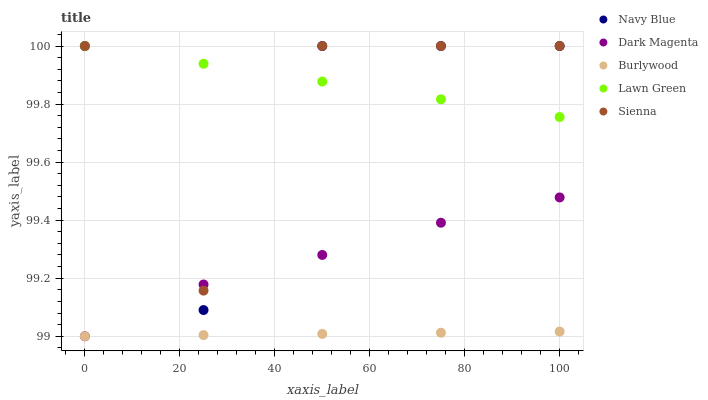Does Burlywood have the minimum area under the curve?
Answer yes or no. Yes. Does Lawn Green have the maximum area under the curve?
Answer yes or no. Yes. Does Navy Blue have the minimum area under the curve?
Answer yes or no. No. Does Navy Blue have the maximum area under the curve?
Answer yes or no. No. Is Lawn Green the smoothest?
Answer yes or no. Yes. Is Navy Blue the roughest?
Answer yes or no. Yes. Is Sienna the smoothest?
Answer yes or no. No. Is Sienna the roughest?
Answer yes or no. No. Does Burlywood have the lowest value?
Answer yes or no. Yes. Does Navy Blue have the lowest value?
Answer yes or no. No. Does Lawn Green have the highest value?
Answer yes or no. Yes. Does Dark Magenta have the highest value?
Answer yes or no. No. Is Dark Magenta less than Lawn Green?
Answer yes or no. Yes. Is Navy Blue greater than Burlywood?
Answer yes or no. Yes. Does Sienna intersect Navy Blue?
Answer yes or no. Yes. Is Sienna less than Navy Blue?
Answer yes or no. No. Is Sienna greater than Navy Blue?
Answer yes or no. No. Does Dark Magenta intersect Lawn Green?
Answer yes or no. No. 